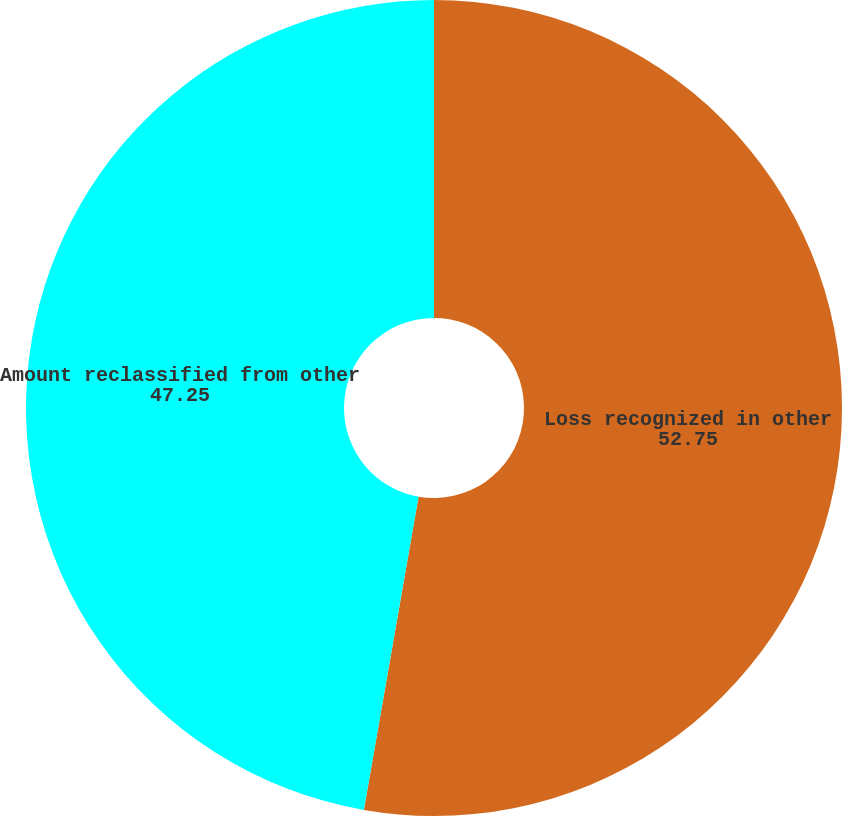Convert chart. <chart><loc_0><loc_0><loc_500><loc_500><pie_chart><fcel>Loss recognized in other<fcel>Amount reclassified from other<nl><fcel>52.75%<fcel>47.25%<nl></chart> 